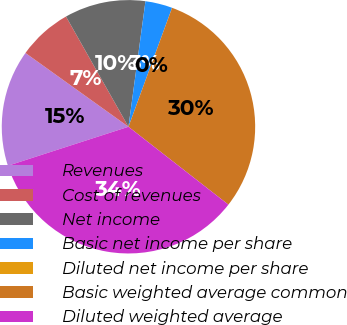Convert chart. <chart><loc_0><loc_0><loc_500><loc_500><pie_chart><fcel>Revenues<fcel>Cost of revenues<fcel>Net income<fcel>Basic net income per share<fcel>Diluted net income per share<fcel>Basic weighted average common<fcel>Diluted weighted average<nl><fcel>14.87%<fcel>6.9%<fcel>10.35%<fcel>3.45%<fcel>0.0%<fcel>29.94%<fcel>34.49%<nl></chart> 